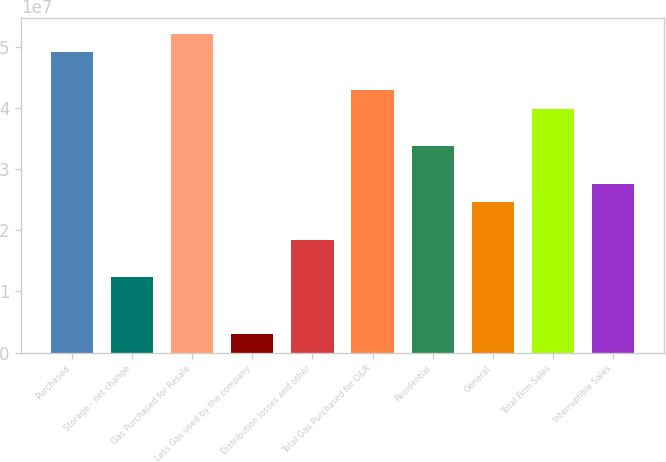Convert chart to OTSL. <chart><loc_0><loc_0><loc_500><loc_500><bar_chart><fcel>Purchased<fcel>Storage - net change<fcel>Gas Purchased for Resale<fcel>Less Gas used by the company<fcel>Distribution losses and other<fcel>Total Gas Purchased for O&R<fcel>Residential<fcel>General<fcel>Total Firm Sales<fcel>Interruptible Sales<nl><fcel>4.90586e+07<fcel>1.23049e+07<fcel>5.21215e+07<fcel>3.1165e+06<fcel>1.84305e+07<fcel>4.2933e+07<fcel>3.37446e+07<fcel>2.45562e+07<fcel>3.98702e+07<fcel>2.7619e+07<nl></chart> 